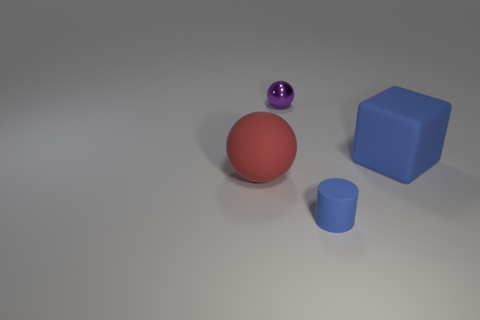Add 4 green metal balls. How many objects exist? 8 Subtract all cubes. How many objects are left? 3 Add 3 small purple metal things. How many small purple metal things are left? 4 Add 4 big red matte cylinders. How many big red matte cylinders exist? 4 Subtract 0 red cylinders. How many objects are left? 4 Subtract all small green matte blocks. Subtract all matte things. How many objects are left? 1 